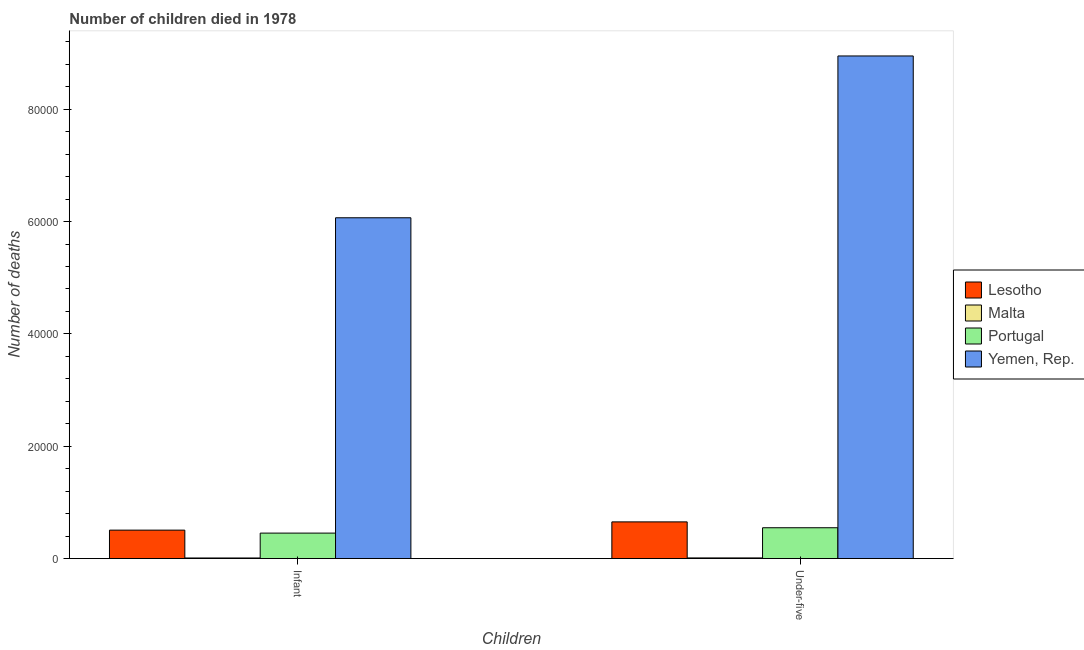How many different coloured bars are there?
Provide a succinct answer. 4. How many groups of bars are there?
Your response must be concise. 2. Are the number of bars per tick equal to the number of legend labels?
Ensure brevity in your answer.  Yes. How many bars are there on the 2nd tick from the right?
Offer a very short reply. 4. What is the label of the 2nd group of bars from the left?
Your answer should be compact. Under-five. What is the number of infant deaths in Lesotho?
Offer a very short reply. 5064. Across all countries, what is the maximum number of under-five deaths?
Your answer should be very brief. 8.95e+04. Across all countries, what is the minimum number of under-five deaths?
Give a very brief answer. 117. In which country was the number of under-five deaths maximum?
Offer a very short reply. Yemen, Rep. In which country was the number of infant deaths minimum?
Provide a succinct answer. Malta. What is the total number of infant deaths in the graph?
Offer a terse response. 7.04e+04. What is the difference between the number of under-five deaths in Portugal and that in Malta?
Make the answer very short. 5371. What is the difference between the number of under-five deaths in Yemen, Rep. and the number of infant deaths in Lesotho?
Keep it short and to the point. 8.44e+04. What is the average number of under-five deaths per country?
Give a very brief answer. 2.54e+04. What is the difference between the number of infant deaths and number of under-five deaths in Lesotho?
Offer a very short reply. -1468. In how many countries, is the number of infant deaths greater than 88000 ?
Keep it short and to the point. 0. What is the ratio of the number of infant deaths in Lesotho to that in Portugal?
Make the answer very short. 1.12. In how many countries, is the number of infant deaths greater than the average number of infant deaths taken over all countries?
Give a very brief answer. 1. What does the 3rd bar from the left in Infant represents?
Your answer should be compact. Portugal. What does the 4th bar from the right in Under-five represents?
Make the answer very short. Lesotho. Are all the bars in the graph horizontal?
Provide a short and direct response. No. How many countries are there in the graph?
Ensure brevity in your answer.  4. Where does the legend appear in the graph?
Provide a succinct answer. Center right. How are the legend labels stacked?
Make the answer very short. Vertical. What is the title of the graph?
Your answer should be very brief. Number of children died in 1978. What is the label or title of the X-axis?
Offer a very short reply. Children. What is the label or title of the Y-axis?
Offer a terse response. Number of deaths. What is the Number of deaths of Lesotho in Infant?
Your answer should be compact. 5064. What is the Number of deaths of Malta in Infant?
Provide a short and direct response. 104. What is the Number of deaths in Portugal in Infant?
Make the answer very short. 4533. What is the Number of deaths of Yemen, Rep. in Infant?
Ensure brevity in your answer.  6.07e+04. What is the Number of deaths in Lesotho in Under-five?
Ensure brevity in your answer.  6532. What is the Number of deaths in Malta in Under-five?
Your answer should be very brief. 117. What is the Number of deaths of Portugal in Under-five?
Your answer should be very brief. 5488. What is the Number of deaths of Yemen, Rep. in Under-five?
Keep it short and to the point. 8.95e+04. Across all Children, what is the maximum Number of deaths of Lesotho?
Give a very brief answer. 6532. Across all Children, what is the maximum Number of deaths in Malta?
Make the answer very short. 117. Across all Children, what is the maximum Number of deaths in Portugal?
Make the answer very short. 5488. Across all Children, what is the maximum Number of deaths of Yemen, Rep.?
Offer a terse response. 8.95e+04. Across all Children, what is the minimum Number of deaths in Lesotho?
Your response must be concise. 5064. Across all Children, what is the minimum Number of deaths of Malta?
Offer a very short reply. 104. Across all Children, what is the minimum Number of deaths of Portugal?
Offer a terse response. 4533. Across all Children, what is the minimum Number of deaths in Yemen, Rep.?
Your response must be concise. 6.07e+04. What is the total Number of deaths in Lesotho in the graph?
Offer a terse response. 1.16e+04. What is the total Number of deaths in Malta in the graph?
Offer a very short reply. 221. What is the total Number of deaths of Portugal in the graph?
Ensure brevity in your answer.  1.00e+04. What is the total Number of deaths in Yemen, Rep. in the graph?
Make the answer very short. 1.50e+05. What is the difference between the Number of deaths in Lesotho in Infant and that in Under-five?
Provide a succinct answer. -1468. What is the difference between the Number of deaths of Portugal in Infant and that in Under-five?
Ensure brevity in your answer.  -955. What is the difference between the Number of deaths in Yemen, Rep. in Infant and that in Under-five?
Offer a very short reply. -2.88e+04. What is the difference between the Number of deaths of Lesotho in Infant and the Number of deaths of Malta in Under-five?
Keep it short and to the point. 4947. What is the difference between the Number of deaths in Lesotho in Infant and the Number of deaths in Portugal in Under-five?
Make the answer very short. -424. What is the difference between the Number of deaths of Lesotho in Infant and the Number of deaths of Yemen, Rep. in Under-five?
Offer a very short reply. -8.44e+04. What is the difference between the Number of deaths of Malta in Infant and the Number of deaths of Portugal in Under-five?
Offer a terse response. -5384. What is the difference between the Number of deaths in Malta in Infant and the Number of deaths in Yemen, Rep. in Under-five?
Keep it short and to the point. -8.94e+04. What is the difference between the Number of deaths in Portugal in Infant and the Number of deaths in Yemen, Rep. in Under-five?
Your response must be concise. -8.50e+04. What is the average Number of deaths in Lesotho per Children?
Your response must be concise. 5798. What is the average Number of deaths of Malta per Children?
Offer a very short reply. 110.5. What is the average Number of deaths in Portugal per Children?
Provide a short and direct response. 5010.5. What is the average Number of deaths in Yemen, Rep. per Children?
Provide a short and direct response. 7.51e+04. What is the difference between the Number of deaths in Lesotho and Number of deaths in Malta in Infant?
Make the answer very short. 4960. What is the difference between the Number of deaths in Lesotho and Number of deaths in Portugal in Infant?
Make the answer very short. 531. What is the difference between the Number of deaths in Lesotho and Number of deaths in Yemen, Rep. in Infant?
Ensure brevity in your answer.  -5.56e+04. What is the difference between the Number of deaths in Malta and Number of deaths in Portugal in Infant?
Your response must be concise. -4429. What is the difference between the Number of deaths of Malta and Number of deaths of Yemen, Rep. in Infant?
Ensure brevity in your answer.  -6.06e+04. What is the difference between the Number of deaths of Portugal and Number of deaths of Yemen, Rep. in Infant?
Provide a short and direct response. -5.61e+04. What is the difference between the Number of deaths of Lesotho and Number of deaths of Malta in Under-five?
Keep it short and to the point. 6415. What is the difference between the Number of deaths of Lesotho and Number of deaths of Portugal in Under-five?
Your answer should be very brief. 1044. What is the difference between the Number of deaths of Lesotho and Number of deaths of Yemen, Rep. in Under-five?
Your response must be concise. -8.30e+04. What is the difference between the Number of deaths in Malta and Number of deaths in Portugal in Under-five?
Make the answer very short. -5371. What is the difference between the Number of deaths of Malta and Number of deaths of Yemen, Rep. in Under-five?
Make the answer very short. -8.94e+04. What is the difference between the Number of deaths in Portugal and Number of deaths in Yemen, Rep. in Under-five?
Your answer should be very brief. -8.40e+04. What is the ratio of the Number of deaths in Lesotho in Infant to that in Under-five?
Your response must be concise. 0.78. What is the ratio of the Number of deaths in Malta in Infant to that in Under-five?
Your answer should be compact. 0.89. What is the ratio of the Number of deaths of Portugal in Infant to that in Under-five?
Provide a short and direct response. 0.83. What is the ratio of the Number of deaths in Yemen, Rep. in Infant to that in Under-five?
Provide a short and direct response. 0.68. What is the difference between the highest and the second highest Number of deaths of Lesotho?
Your response must be concise. 1468. What is the difference between the highest and the second highest Number of deaths in Portugal?
Offer a very short reply. 955. What is the difference between the highest and the second highest Number of deaths in Yemen, Rep.?
Ensure brevity in your answer.  2.88e+04. What is the difference between the highest and the lowest Number of deaths in Lesotho?
Make the answer very short. 1468. What is the difference between the highest and the lowest Number of deaths in Malta?
Give a very brief answer. 13. What is the difference between the highest and the lowest Number of deaths in Portugal?
Provide a short and direct response. 955. What is the difference between the highest and the lowest Number of deaths of Yemen, Rep.?
Provide a short and direct response. 2.88e+04. 